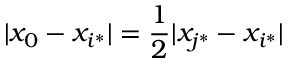Convert formula to latex. <formula><loc_0><loc_0><loc_500><loc_500>| x _ { 0 } - x _ { i ^ { \ast } } | = \frac { 1 } { 2 } | x _ { j ^ { \ast } } - x _ { i ^ { \ast } } |</formula> 